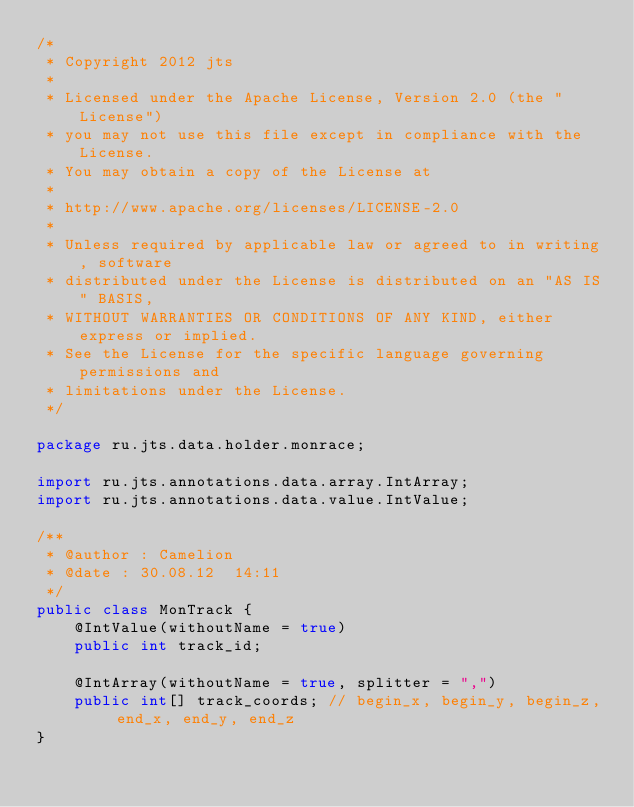<code> <loc_0><loc_0><loc_500><loc_500><_Java_>/*
 * Copyright 2012 jts
 *
 * Licensed under the Apache License, Version 2.0 (the "License")
 * you may not use this file except in compliance with the License.
 * You may obtain a copy of the License at
 *
 * http://www.apache.org/licenses/LICENSE-2.0
 *
 * Unless required by applicable law or agreed to in writing, software
 * distributed under the License is distributed on an "AS IS" BASIS,
 * WITHOUT WARRANTIES OR CONDITIONS OF ANY KIND, either express or implied.
 * See the License for the specific language governing permissions and
 * limitations under the License.
 */

package ru.jts.data.holder.monrace;

import ru.jts.annotations.data.array.IntArray;
import ru.jts.annotations.data.value.IntValue;

/**
 * @author : Camelion
 * @date : 30.08.12  14:11
 */
public class MonTrack {
    @IntValue(withoutName = true)
    public int track_id;

    @IntArray(withoutName = true, splitter = ",")
    public int[] track_coords; // begin_x, begin_y, begin_z, end_x, end_y, end_z
}
</code> 